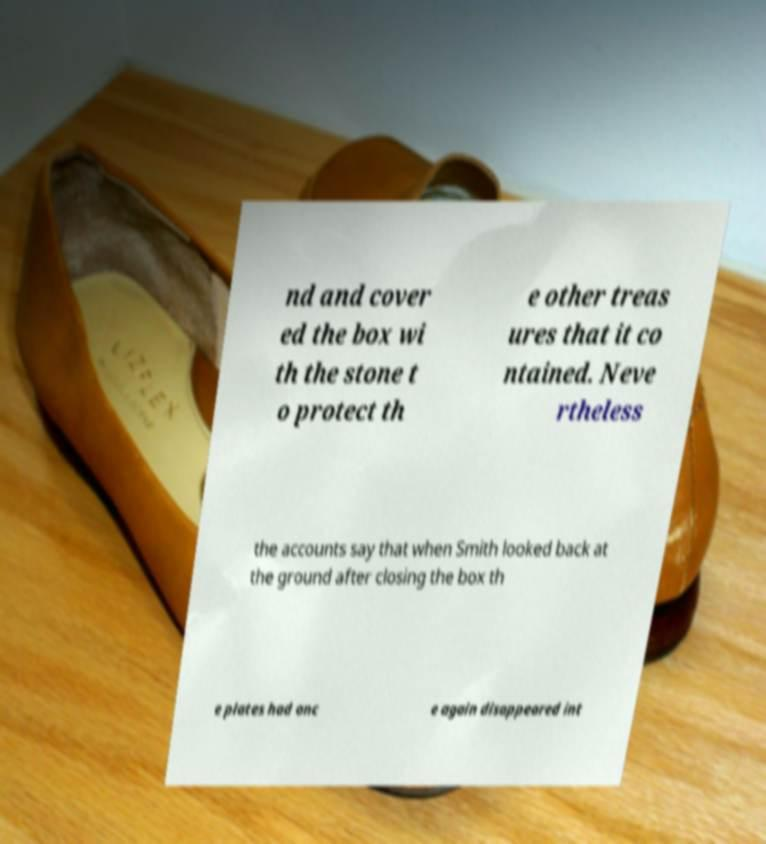I need the written content from this picture converted into text. Can you do that? nd and cover ed the box wi th the stone t o protect th e other treas ures that it co ntained. Neve rtheless the accounts say that when Smith looked back at the ground after closing the box th e plates had onc e again disappeared int 